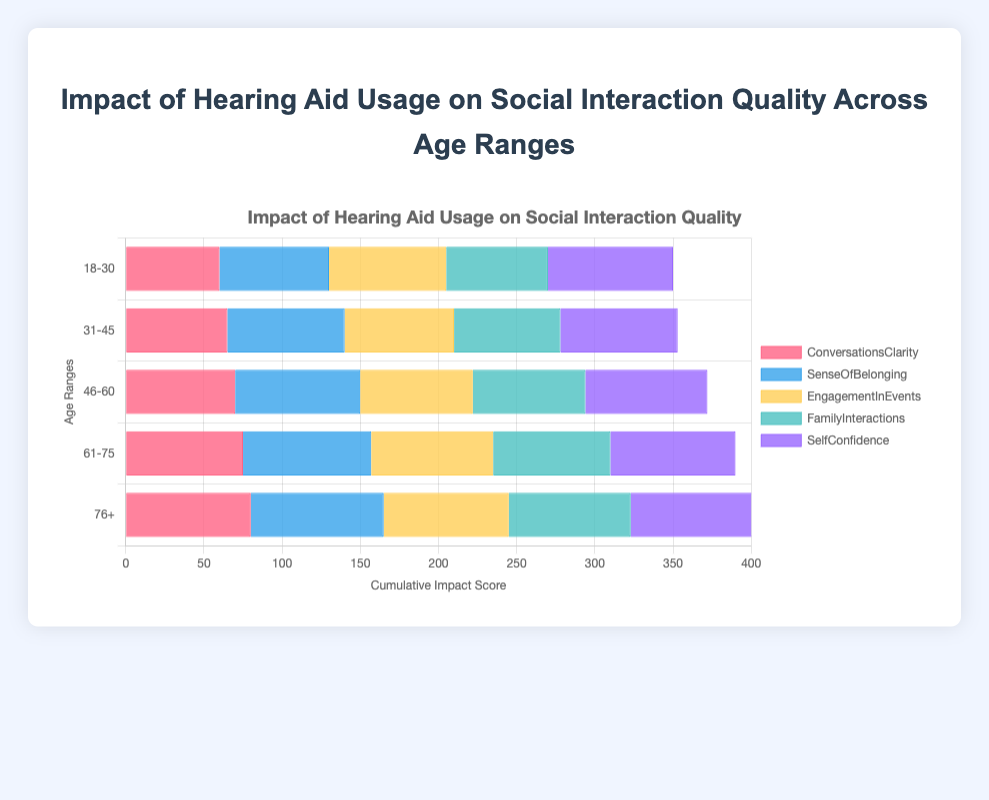What is the overall trend of "SelfConfidence" improvement with age? From the chart, "SelfConfidence" shows increasing scores across age ranges. It starts at 80 for the 18-30 age group and increases to 82 for the 76+ age group.
Answer: SelfConfidence improves with age Among the age ranges 31-45 and 46-60, which age range has a higher impact score for "EngagementInEvents"? The chart indicates that the impact score for "EngagementInEvents" is 70 for the 31-45 age range and 72 for the 46-60 age range. Comparing these two, 46-60 has a higher score.
Answer: 46-60 What is the sum of the impact scores for "ConversationsClarity" and "FamilyInteractions" in the 61-75 age range? According to the chart, the impact scores are 75 for "ConversationsClarity" and 75 for "FamilyInteractions". Summing these scores: 75 + 75 = 150.
Answer: 150 Which color represents the factor "SenseOfBelonging"? The factor "SenseOfBelonging" is represented by the second color in the chart's legend, which is blue.
Answer: Blue How does the "EngagementInEvents" impact score for the 76+ age range compare to the score for the 18-30 age range? The chart shows that the "EngagementInEvents" score is 75 for the 18-30 age range and 80 for the 76+ age range. The impact score is higher in the 76+ age range.
Answer: 76+ age range has a higher score What is the average "ConversationsClarity" score across all age ranges? The "ConversationsClarity" scores across the age ranges are 60, 65, 70, 75, and 80. Calculating the average: (60 + 65 + 70 + 75 + 80) / 5 = 70.
Answer: 70 For which age range is the cumulative impact score the highest? By comparing the total height of the horizontal bars across age ranges, the 76+ age range has the highest cumulative impact score.
Answer: 76+ By how much does "SenseOfBelonging" improve from the 18-30 age range to the 61-75 age range? The "SenseOfBelonging" score is 70 for the 18-30 age range and 82 for the 61-75 age range. The improvement is 82 - 70 = 12 points.
Answer: 12 points Which two age ranges have the closest scores for "FamilyInteractions"? The chart shows scores for "FamilyInteractions" as 65 (18-30), 68 (31-45), 72 (46-60), 75 (61-75), and 78 (76+). The closest scores are 72 (46-60) and 75 (61-75), with a difference of 3 points.
Answer: 46-60 and 61-75 